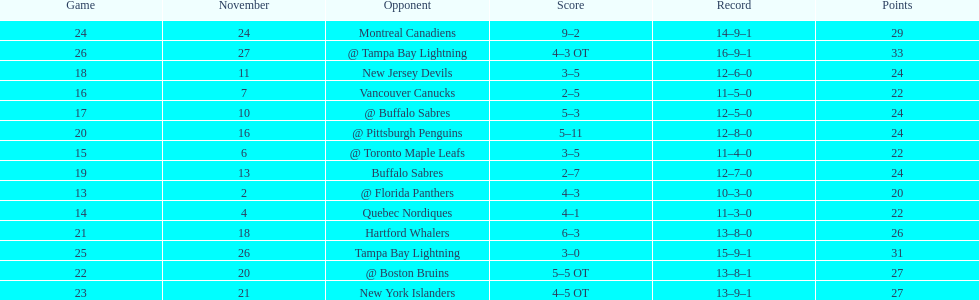What was the number of wins the philadelphia flyers had? 35. 